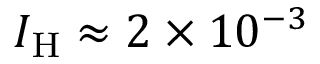<formula> <loc_0><loc_0><loc_500><loc_500>I _ { H } \approx 2 \times 1 0 ^ { - 3 }</formula> 